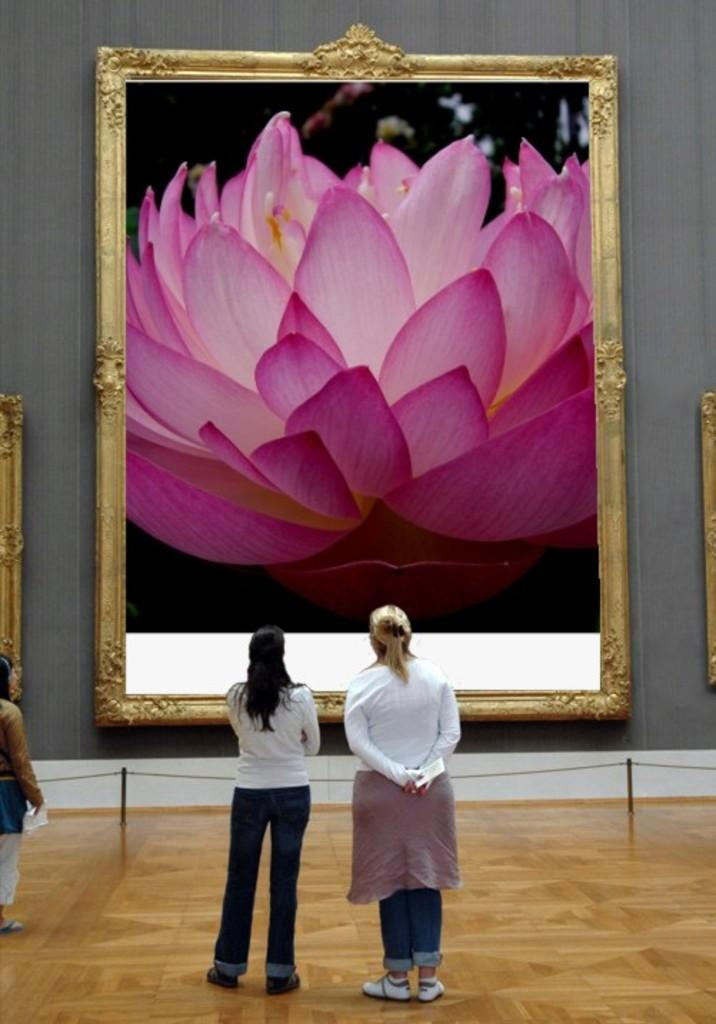What are the people in the image doing? The persons standing on the floor in the image are likely observing or interacting with something. What is in front of the persons in the image? There is a fence in front of the persons in the image. What can be seen on the wall in the image? There are frames attached to the wall in the image, and they contain pictures of a lotus flower. How long does it take for the game to finish in the image? There is no game present in the image, so it is not possible to determine how long it would take to finish. 